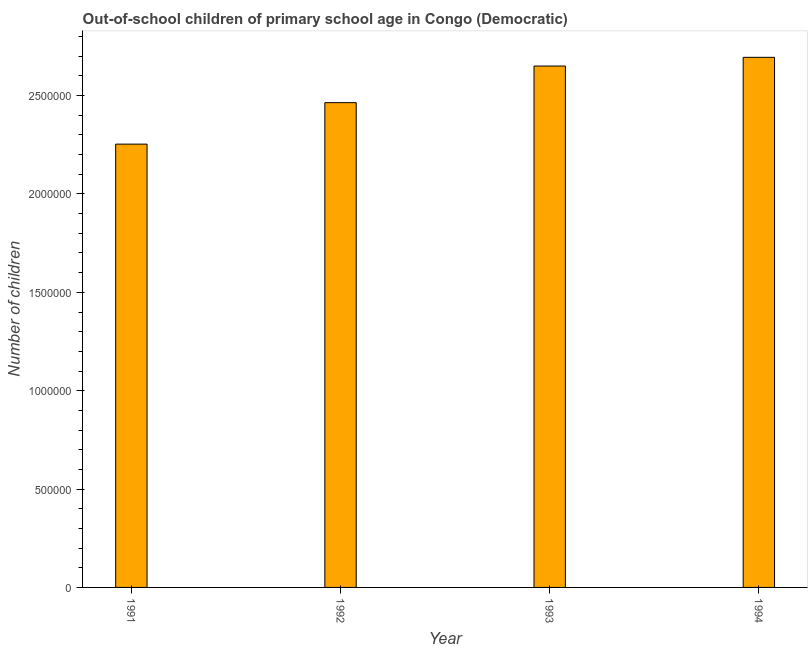Does the graph contain any zero values?
Your response must be concise. No. Does the graph contain grids?
Keep it short and to the point. No. What is the title of the graph?
Provide a short and direct response. Out-of-school children of primary school age in Congo (Democratic). What is the label or title of the X-axis?
Offer a terse response. Year. What is the label or title of the Y-axis?
Offer a terse response. Number of children. What is the number of out-of-school children in 1992?
Your response must be concise. 2.46e+06. Across all years, what is the maximum number of out-of-school children?
Your answer should be compact. 2.69e+06. Across all years, what is the minimum number of out-of-school children?
Your answer should be compact. 2.25e+06. In which year was the number of out-of-school children maximum?
Keep it short and to the point. 1994. What is the sum of the number of out-of-school children?
Provide a succinct answer. 1.01e+07. What is the difference between the number of out-of-school children in 1991 and 1994?
Offer a very short reply. -4.41e+05. What is the average number of out-of-school children per year?
Give a very brief answer. 2.52e+06. What is the median number of out-of-school children?
Make the answer very short. 2.56e+06. In how many years, is the number of out-of-school children greater than 1800000 ?
Your answer should be very brief. 4. What is the ratio of the number of out-of-school children in 1992 to that in 1993?
Give a very brief answer. 0.93. What is the difference between the highest and the second highest number of out-of-school children?
Provide a succinct answer. 4.42e+04. Is the sum of the number of out-of-school children in 1991 and 1992 greater than the maximum number of out-of-school children across all years?
Provide a succinct answer. Yes. What is the difference between the highest and the lowest number of out-of-school children?
Your response must be concise. 4.41e+05. In how many years, is the number of out-of-school children greater than the average number of out-of-school children taken over all years?
Offer a very short reply. 2. How many bars are there?
Provide a short and direct response. 4. What is the difference between two consecutive major ticks on the Y-axis?
Keep it short and to the point. 5.00e+05. What is the Number of children of 1991?
Provide a short and direct response. 2.25e+06. What is the Number of children in 1992?
Provide a short and direct response. 2.46e+06. What is the Number of children of 1993?
Offer a terse response. 2.65e+06. What is the Number of children in 1994?
Your answer should be very brief. 2.69e+06. What is the difference between the Number of children in 1991 and 1992?
Provide a succinct answer. -2.11e+05. What is the difference between the Number of children in 1991 and 1993?
Keep it short and to the point. -3.97e+05. What is the difference between the Number of children in 1991 and 1994?
Give a very brief answer. -4.41e+05. What is the difference between the Number of children in 1992 and 1993?
Your answer should be compact. -1.86e+05. What is the difference between the Number of children in 1992 and 1994?
Provide a short and direct response. -2.30e+05. What is the difference between the Number of children in 1993 and 1994?
Your answer should be compact. -4.42e+04. What is the ratio of the Number of children in 1991 to that in 1992?
Provide a short and direct response. 0.91. What is the ratio of the Number of children in 1991 to that in 1993?
Give a very brief answer. 0.85. What is the ratio of the Number of children in 1991 to that in 1994?
Ensure brevity in your answer.  0.84. What is the ratio of the Number of children in 1992 to that in 1993?
Make the answer very short. 0.93. What is the ratio of the Number of children in 1992 to that in 1994?
Ensure brevity in your answer.  0.92. What is the ratio of the Number of children in 1993 to that in 1994?
Your answer should be compact. 0.98. 